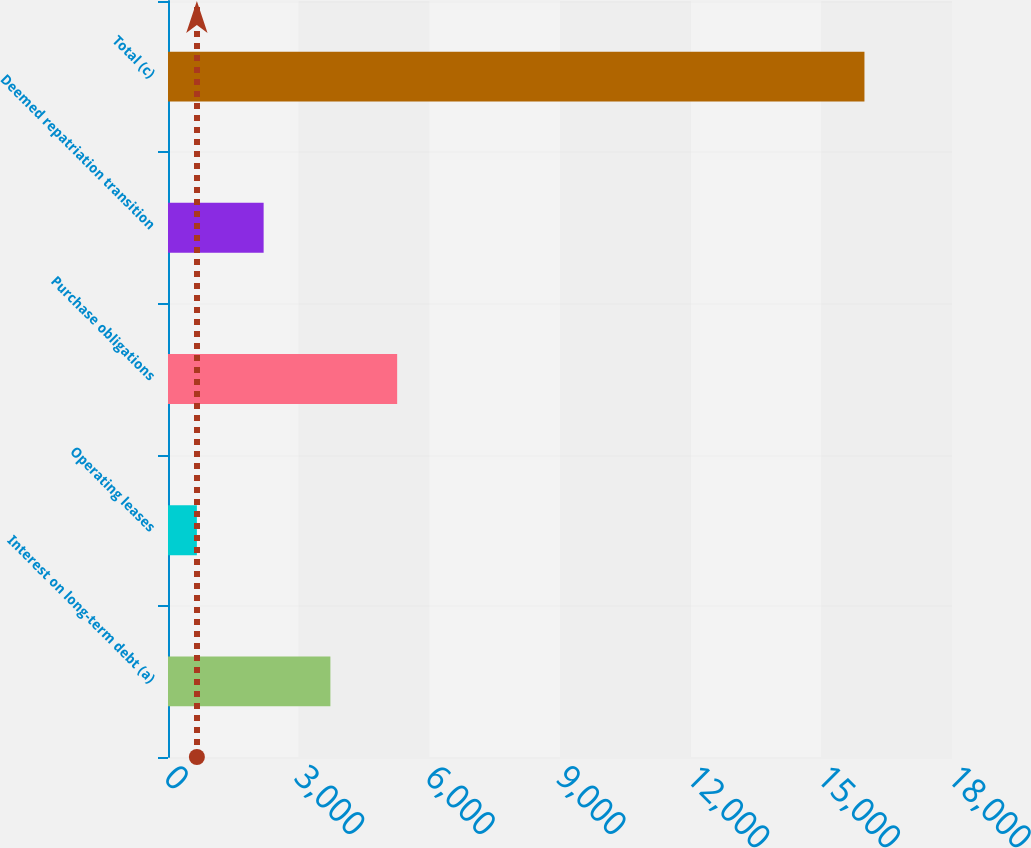Convert chart to OTSL. <chart><loc_0><loc_0><loc_500><loc_500><bar_chart><fcel>Interest on long-term debt (a)<fcel>Operating leases<fcel>Purchase obligations<fcel>Deemed repatriation transition<fcel>Total (c)<nl><fcel>3728.4<fcel>663<fcel>5261.1<fcel>2195.7<fcel>15990<nl></chart> 